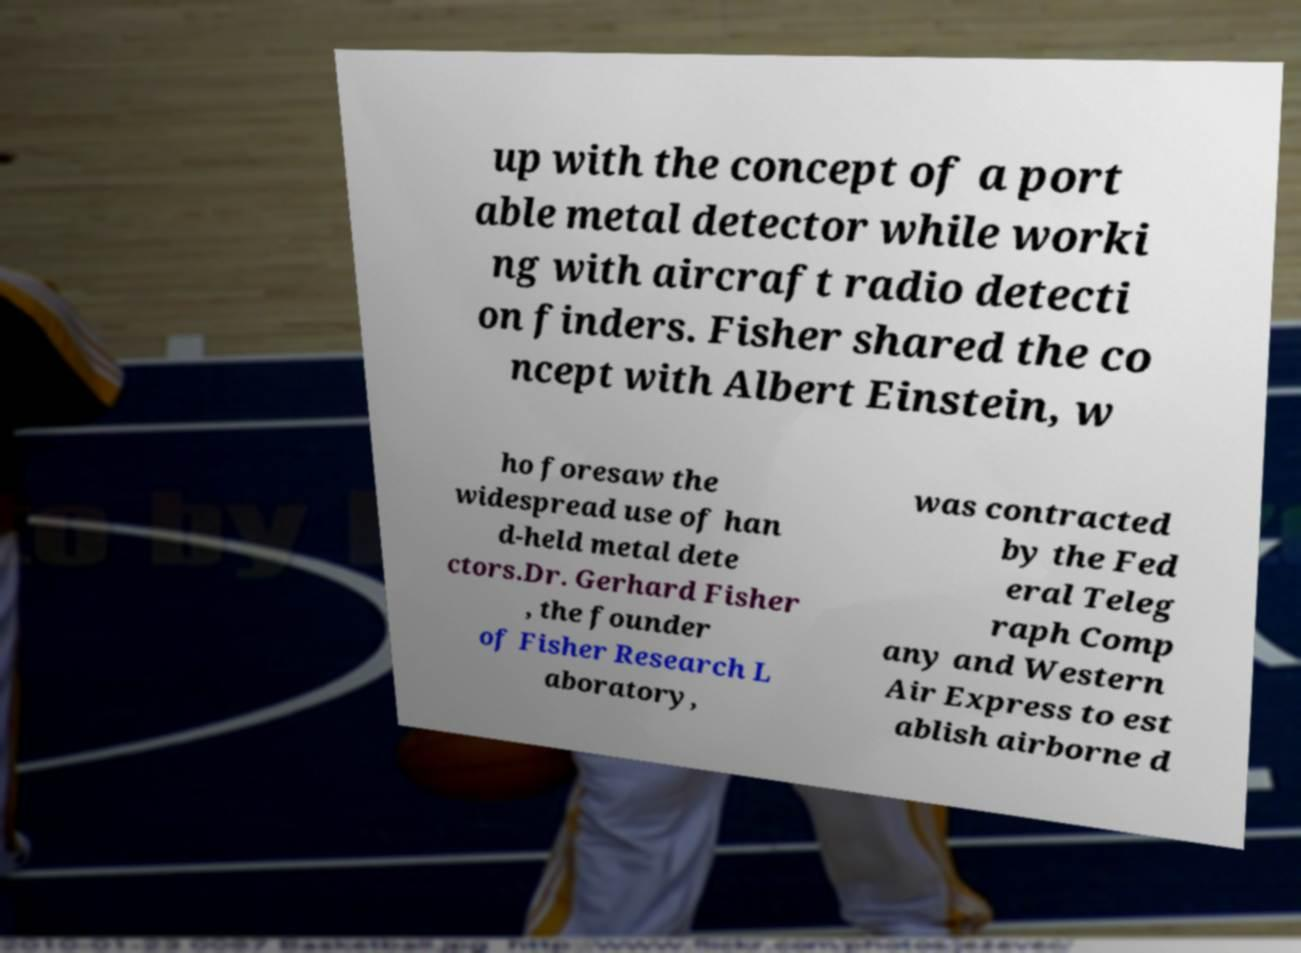There's text embedded in this image that I need extracted. Can you transcribe it verbatim? up with the concept of a port able metal detector while worki ng with aircraft radio detecti on finders. Fisher shared the co ncept with Albert Einstein, w ho foresaw the widespread use of han d-held metal dete ctors.Dr. Gerhard Fisher , the founder of Fisher Research L aboratory, was contracted by the Fed eral Teleg raph Comp any and Western Air Express to est ablish airborne d 